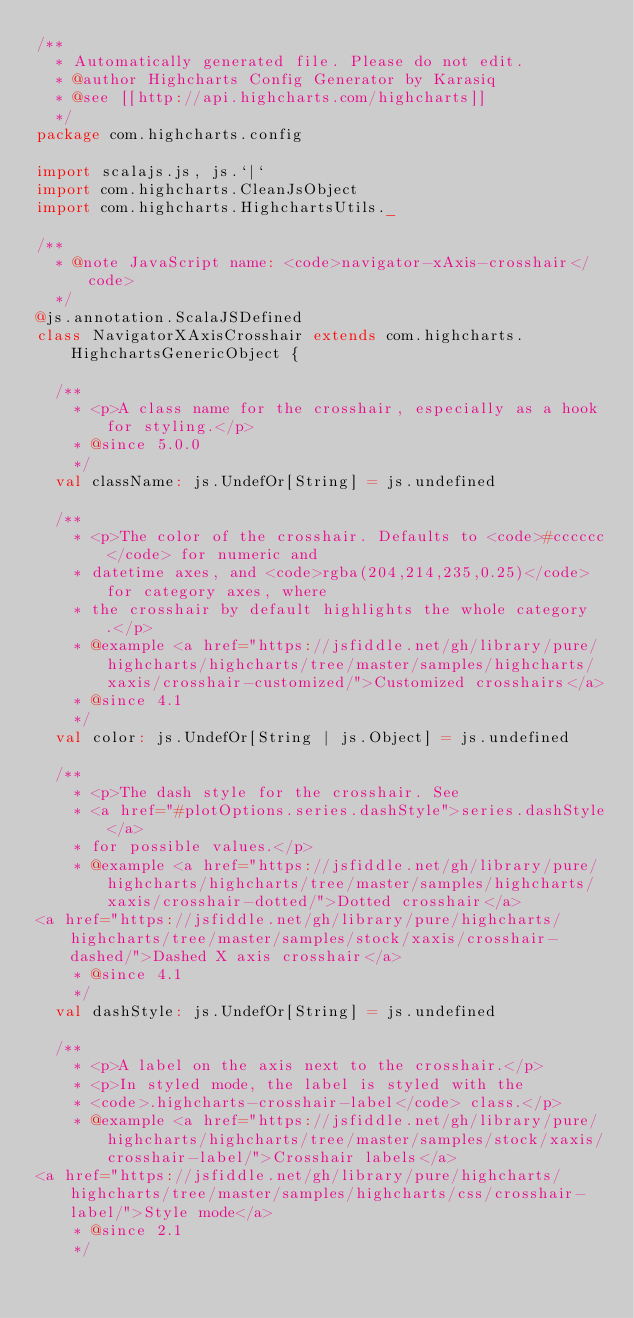Convert code to text. <code><loc_0><loc_0><loc_500><loc_500><_Scala_>/**
  * Automatically generated file. Please do not edit.
  * @author Highcharts Config Generator by Karasiq
  * @see [[http://api.highcharts.com/highcharts]]
  */
package com.highcharts.config

import scalajs.js, js.`|`
import com.highcharts.CleanJsObject
import com.highcharts.HighchartsUtils._

/**
  * @note JavaScript name: <code>navigator-xAxis-crosshair</code>
  */
@js.annotation.ScalaJSDefined
class NavigatorXAxisCrosshair extends com.highcharts.HighchartsGenericObject {

  /**
    * <p>A class name for the crosshair, especially as a hook for styling.</p>
    * @since 5.0.0
    */
  val className: js.UndefOr[String] = js.undefined

  /**
    * <p>The color of the crosshair. Defaults to <code>#cccccc</code> for numeric and
    * datetime axes, and <code>rgba(204,214,235,0.25)</code> for category axes, where
    * the crosshair by default highlights the whole category.</p>
    * @example <a href="https://jsfiddle.net/gh/library/pure/highcharts/highcharts/tree/master/samples/highcharts/xaxis/crosshair-customized/">Customized crosshairs</a>
    * @since 4.1
    */
  val color: js.UndefOr[String | js.Object] = js.undefined

  /**
    * <p>The dash style for the crosshair. See
    * <a href="#plotOptions.series.dashStyle">series.dashStyle</a>
    * for possible values.</p>
    * @example <a href="https://jsfiddle.net/gh/library/pure/highcharts/highcharts/tree/master/samples/highcharts/xaxis/crosshair-dotted/">Dotted crosshair</a>
<a href="https://jsfiddle.net/gh/library/pure/highcharts/highcharts/tree/master/samples/stock/xaxis/crosshair-dashed/">Dashed X axis crosshair</a>
    * @since 4.1
    */
  val dashStyle: js.UndefOr[String] = js.undefined

  /**
    * <p>A label on the axis next to the crosshair.</p>
    * <p>In styled mode, the label is styled with the
    * <code>.highcharts-crosshair-label</code> class.</p>
    * @example <a href="https://jsfiddle.net/gh/library/pure/highcharts/highcharts/tree/master/samples/stock/xaxis/crosshair-label/">Crosshair labels</a>
<a href="https://jsfiddle.net/gh/library/pure/highcharts/highcharts/tree/master/samples/highcharts/css/crosshair-label/">Style mode</a>
    * @since 2.1
    */</code> 